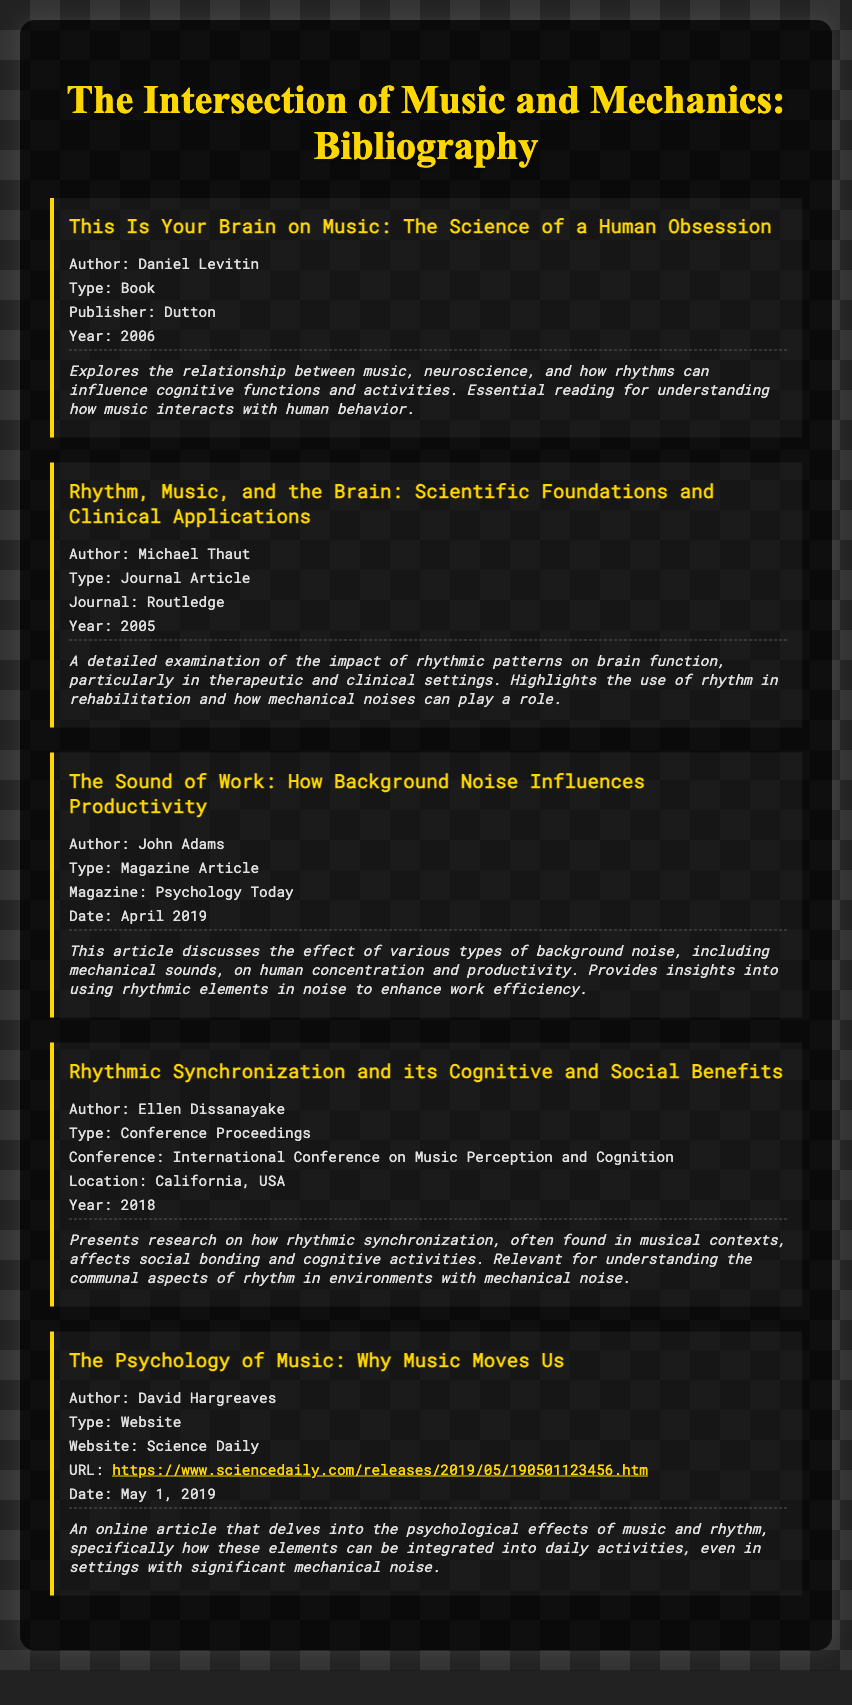What is the title of the first bibliography item? The title is mentioned in the first bibliography entry.
Answer: This Is Your Brain on Music: The Science of a Human Obsession Who is the author of the article "The Sound of Work"? The document lists the authors for each item, and this one is by John Adams.
Answer: John Adams What year was "Rhythm, Music, and the Brain" published? The year is specified in the bibliography entry for this journal article.
Answer: 2005 Which type of document is "The Psychology of Music: Why Music Moves Us"? The document specifies the type of each entry, and this one is identified as a website.
Answer: Website What is the main subject of "Rhythmic Synchronization and its Cognitive and Social Benefits"? The details provide a focus on how rhythmic synchronization affects social bonding and cognitive activities.
Answer: Rhythmic synchronization In what year was the conference for "Rhythmic Synchronization and its Cognitive and Social Benefits"? The year is mentioned in the bibliography entry of the conference proceedings.
Answer: 2018 What is the URL for "The Psychology of Music: Why Music Moves Us"? The specific URL is given in the bibliography for easy reference.
Answer: https://www.sciencedaily.com/releases/2019/05/190501123456.htm What publication features "The Sound of Work"? The publication name is included in the details of this article entry.
Answer: Psychology Today 